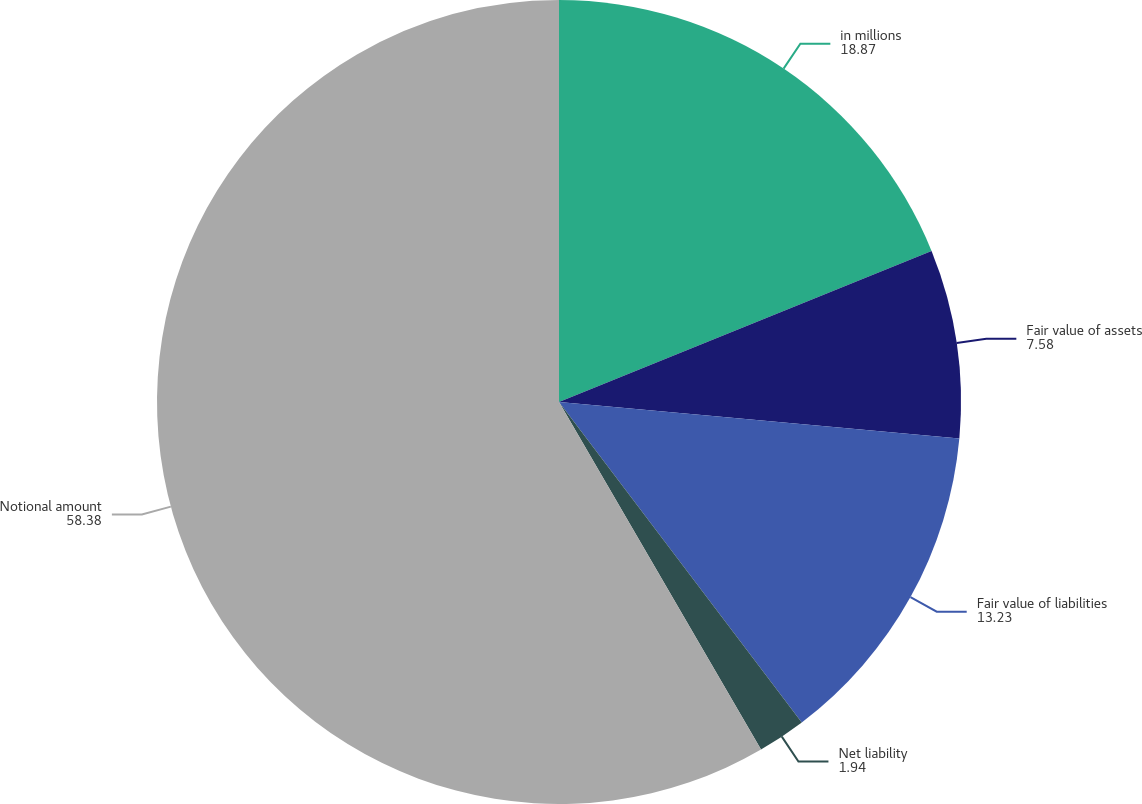<chart> <loc_0><loc_0><loc_500><loc_500><pie_chart><fcel>in millions<fcel>Fair value of assets<fcel>Fair value of liabilities<fcel>Net liability<fcel>Notional amount<nl><fcel>18.87%<fcel>7.58%<fcel>13.23%<fcel>1.94%<fcel>58.38%<nl></chart> 